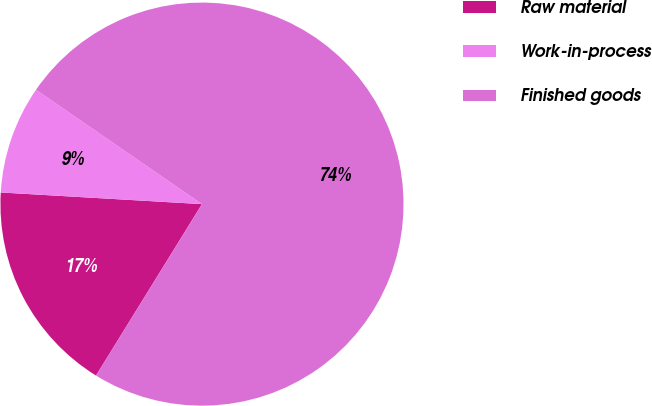Convert chart to OTSL. <chart><loc_0><loc_0><loc_500><loc_500><pie_chart><fcel>Raw material<fcel>Work-in-process<fcel>Finished goods<nl><fcel>17.11%<fcel>8.68%<fcel>74.21%<nl></chart> 